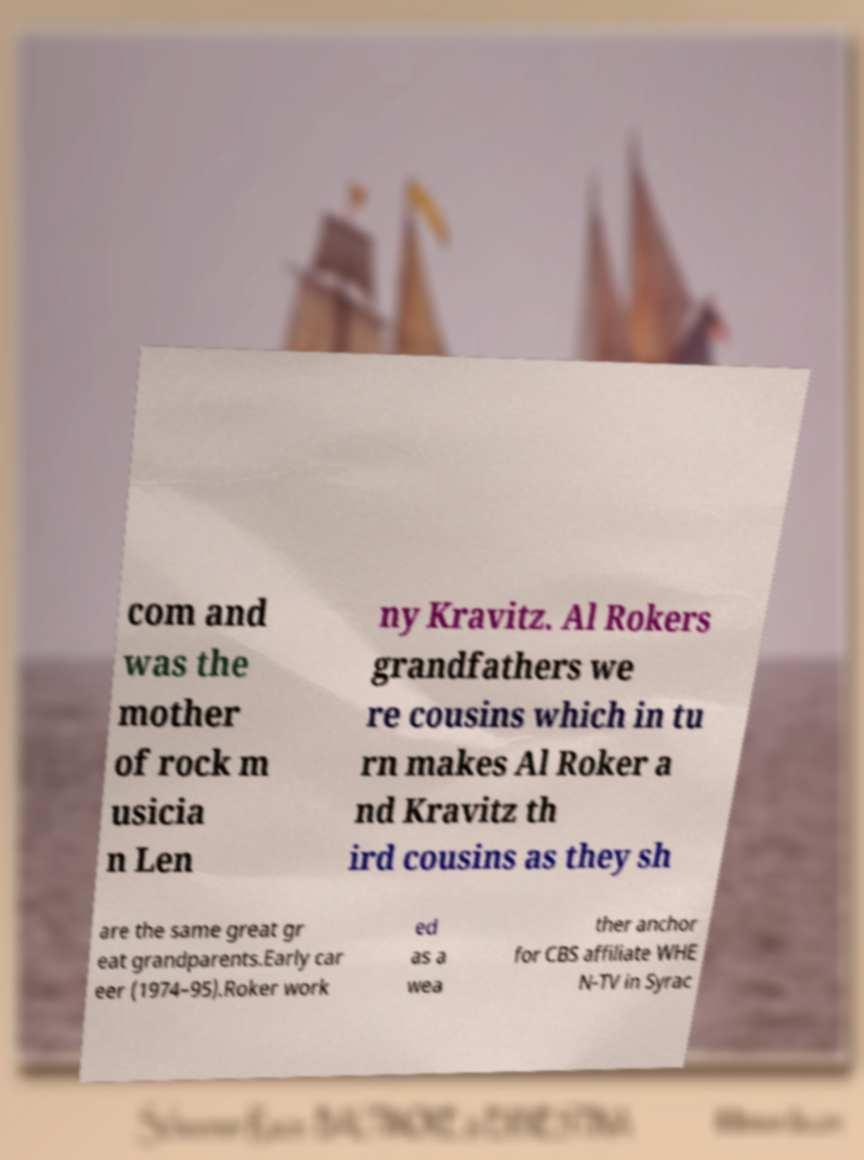Could you extract and type out the text from this image? com and was the mother of rock m usicia n Len ny Kravitz. Al Rokers grandfathers we re cousins which in tu rn makes Al Roker a nd Kravitz th ird cousins as they sh are the same great gr eat grandparents.Early car eer (1974–95).Roker work ed as a wea ther anchor for CBS affiliate WHE N-TV in Syrac 